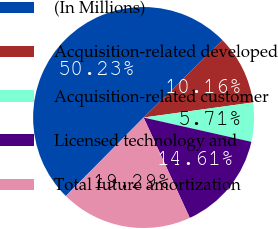Convert chart to OTSL. <chart><loc_0><loc_0><loc_500><loc_500><pie_chart><fcel>(In Millions)<fcel>Acquisition-related developed<fcel>Acquisition-related customer<fcel>Licensed technology and<fcel>Total future amortization<nl><fcel>50.24%<fcel>10.16%<fcel>5.71%<fcel>14.61%<fcel>19.29%<nl></chart> 